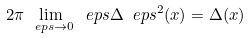<formula> <loc_0><loc_0><loc_500><loc_500>2 \pi \lim _ { \ e p s \to 0 } \ e p s \Delta _ { \ } e p s ^ { 2 } ( x ) = \Delta ( x )</formula> 